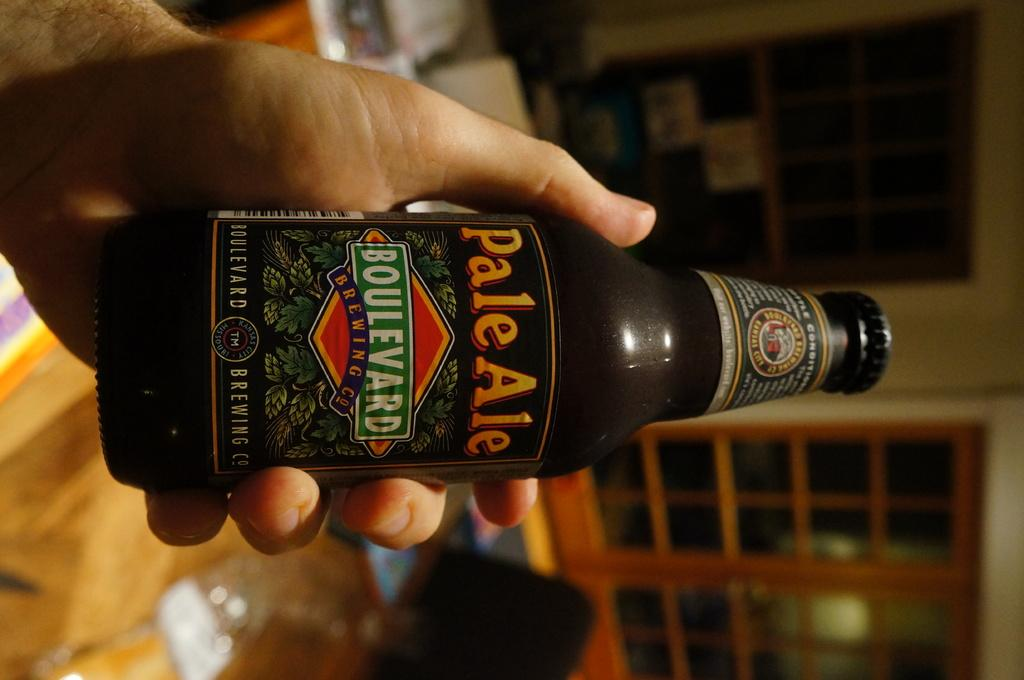What is present in the image that is related to a beverage? There is a bottle in the image. Can you identify the brand of the bottle? The bottle is of brand Boulevard. How is the bottle being held in the image? The bottle is being held by a person's hand. What type of lock is visible on the bottle in the image? There is no lock visible on the bottle in the image. How many screws can be seen on the bottle in the image? There are no screws visible on the bottle in the image. 